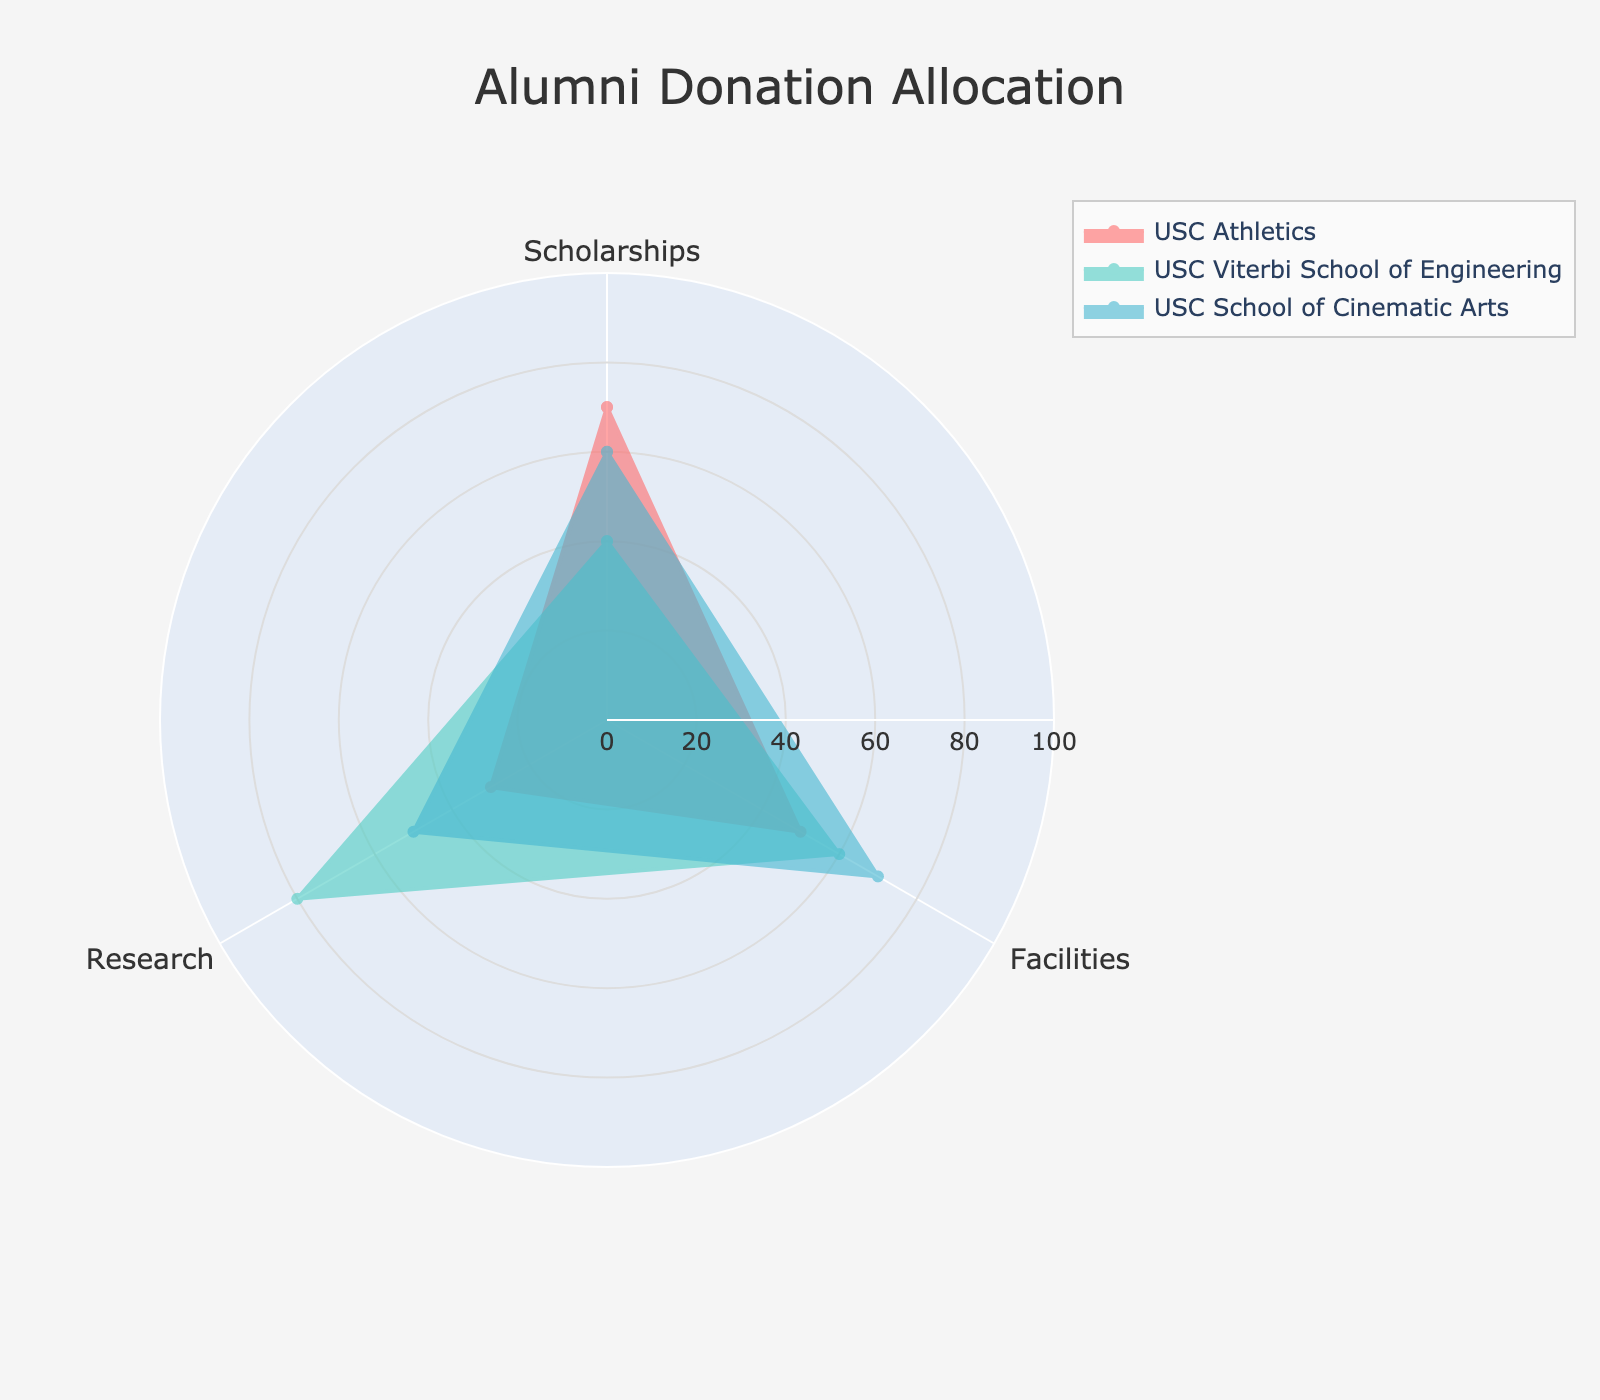What is the title of the radar chart? The title of a radar chart is usually displayed prominently on the top of the figure. In this case, the title is "Alumni Donation Allocation"
Answer: Alumni Donation Allocation What are the three categories/categories shown in the radar chart? The radar chart has axes labeled for each category, which in this case are "Scholarships", "Facilities", and "Research"
Answer: Scholarships, Facilities, Research Which group has the highest allocation for Research? By looking at the segment of the radar chart representing Research, the group with the furthest extension to the edge in the Research category is the USC Viterbi School of Engineering. The value is 80.
Answer: USC Viterbi School of Engineering Which group allocates the least to Facilities? The Facilities axis shows three different allocations across the groups. The group with the lowest value, closest to the center, is USC Athletics with a value of 50.
Answer: USC Athletics How much more does the USC School of Cinematic Arts allocate to Facilities compared to USC Athletics? The value for USC School of Cinematic Arts in Facilities is 70, and for USC Athletics, it is 50. The difference is 70 - 50 = 20.
Answer: 20 Which group has the most balanced allocation across all three categories? A balanced allocation would show similar lengths in each axis of the radar chart. Analyzing the chart, USC School of Cinematic Arts shows the most balanced allocation with values 60, 70, and 50, which are closer to each other than the other groups.
Answer: USC School of Cinematic Arts Which category does USC Athletics allocate the most to? By examining the radar chart for USC Athletics, the highest value is seen in the Scholarships category at 70.
Answer: Scholarships What is the average donation allocation for the USC Viterbi School of Engineering across all categories? To find the average, sum the values for all categories specific to the USC Viterbi School of Engineering: 40 + 60 + 80. The sum is 180. Dividing this by the number of categories (3) gives 180 / 3 = 60.
Answer: 60 What is the total allocation to Scholarships by all groups? Adding the values of Scholarships from all groups: USC Athletics (70), USC Viterbi School of Engineering (40), and USC School of Cinematic Arts (60) gives 70 + 40 + 60 = 170.
Answer: 170 